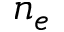<formula> <loc_0><loc_0><loc_500><loc_500>n _ { e }</formula> 